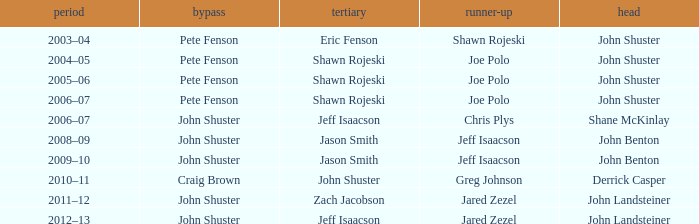Could you parse the entire table as a dict? {'header': ['period', 'bypass', 'tertiary', 'runner-up', 'head'], 'rows': [['2003–04', 'Pete Fenson', 'Eric Fenson', 'Shawn Rojeski', 'John Shuster'], ['2004–05', 'Pete Fenson', 'Shawn Rojeski', 'Joe Polo', 'John Shuster'], ['2005–06', 'Pete Fenson', 'Shawn Rojeski', 'Joe Polo', 'John Shuster'], ['2006–07', 'Pete Fenson', 'Shawn Rojeski', 'Joe Polo', 'John Shuster'], ['2006–07', 'John Shuster', 'Jeff Isaacson', 'Chris Plys', 'Shane McKinlay'], ['2008–09', 'John Shuster', 'Jason Smith', 'Jeff Isaacson', 'John Benton'], ['2009–10', 'John Shuster', 'Jason Smith', 'Jeff Isaacson', 'John Benton'], ['2010–11', 'Craig Brown', 'John Shuster', 'Greg Johnson', 'Derrick Casper'], ['2011–12', 'John Shuster', 'Zach Jacobson', 'Jared Zezel', 'John Landsteiner'], ['2012–13', 'John Shuster', 'Jeff Isaacson', 'Jared Zezel', 'John Landsteiner']]} Who was second when Shane McKinlay was the lead? Chris Plys. 